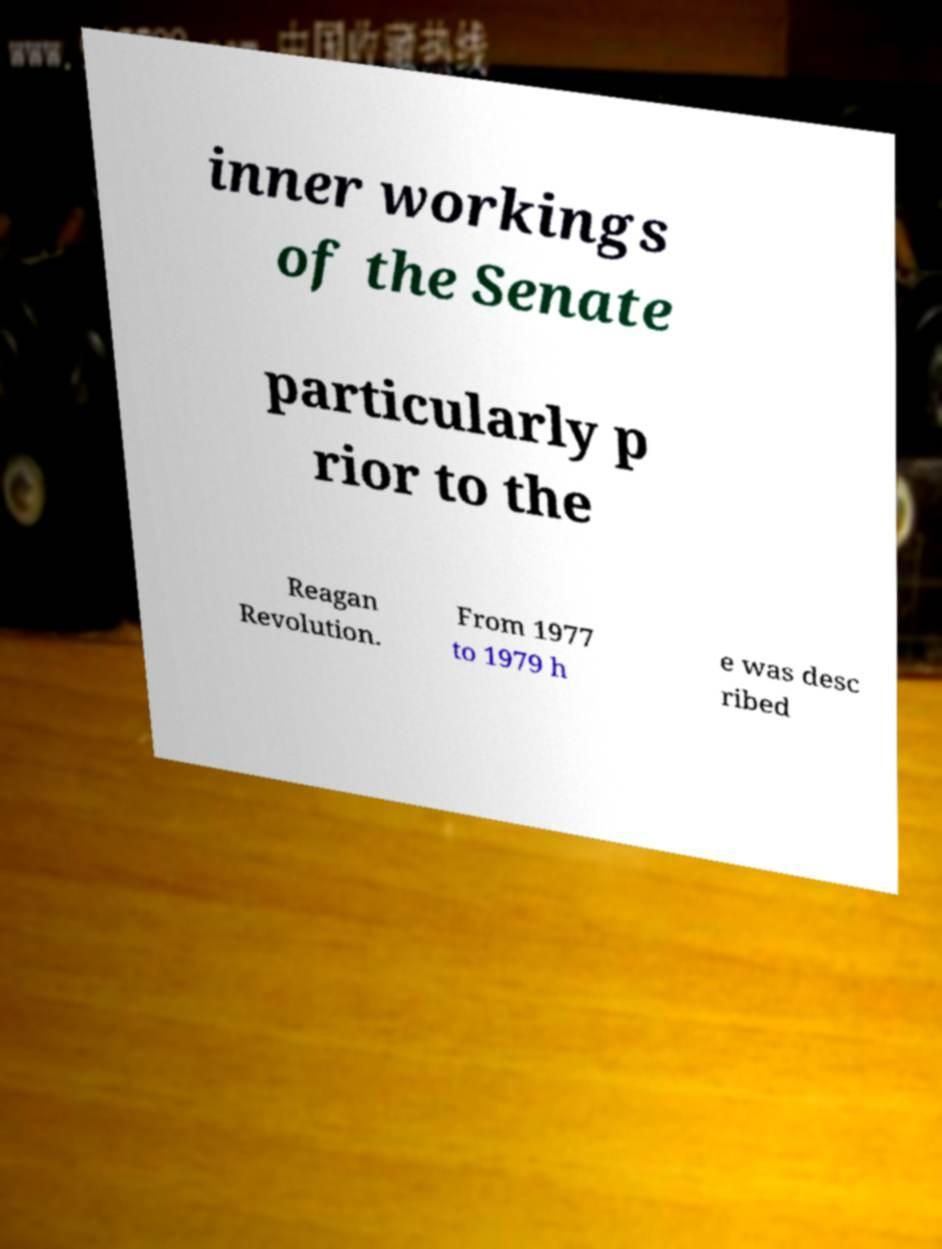What messages or text are displayed in this image? I need them in a readable, typed format. inner workings of the Senate particularly p rior to the Reagan Revolution. From 1977 to 1979 h e was desc ribed 